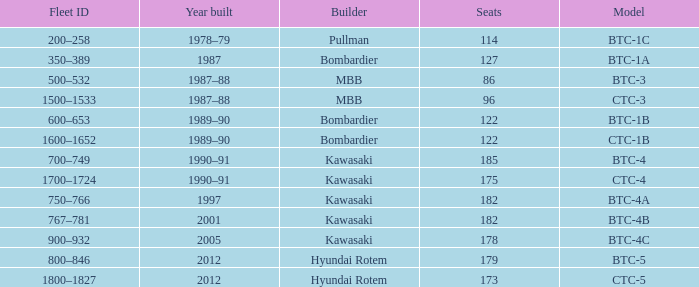In the btc-5 model, what is the total number of seats? 179.0. 